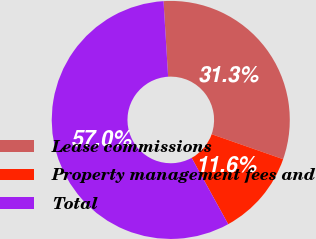<chart> <loc_0><loc_0><loc_500><loc_500><pie_chart><fcel>Lease commissions<fcel>Property management fees and<fcel>Total<nl><fcel>31.32%<fcel>11.64%<fcel>57.04%<nl></chart> 